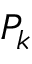<formula> <loc_0><loc_0><loc_500><loc_500>P _ { k }</formula> 